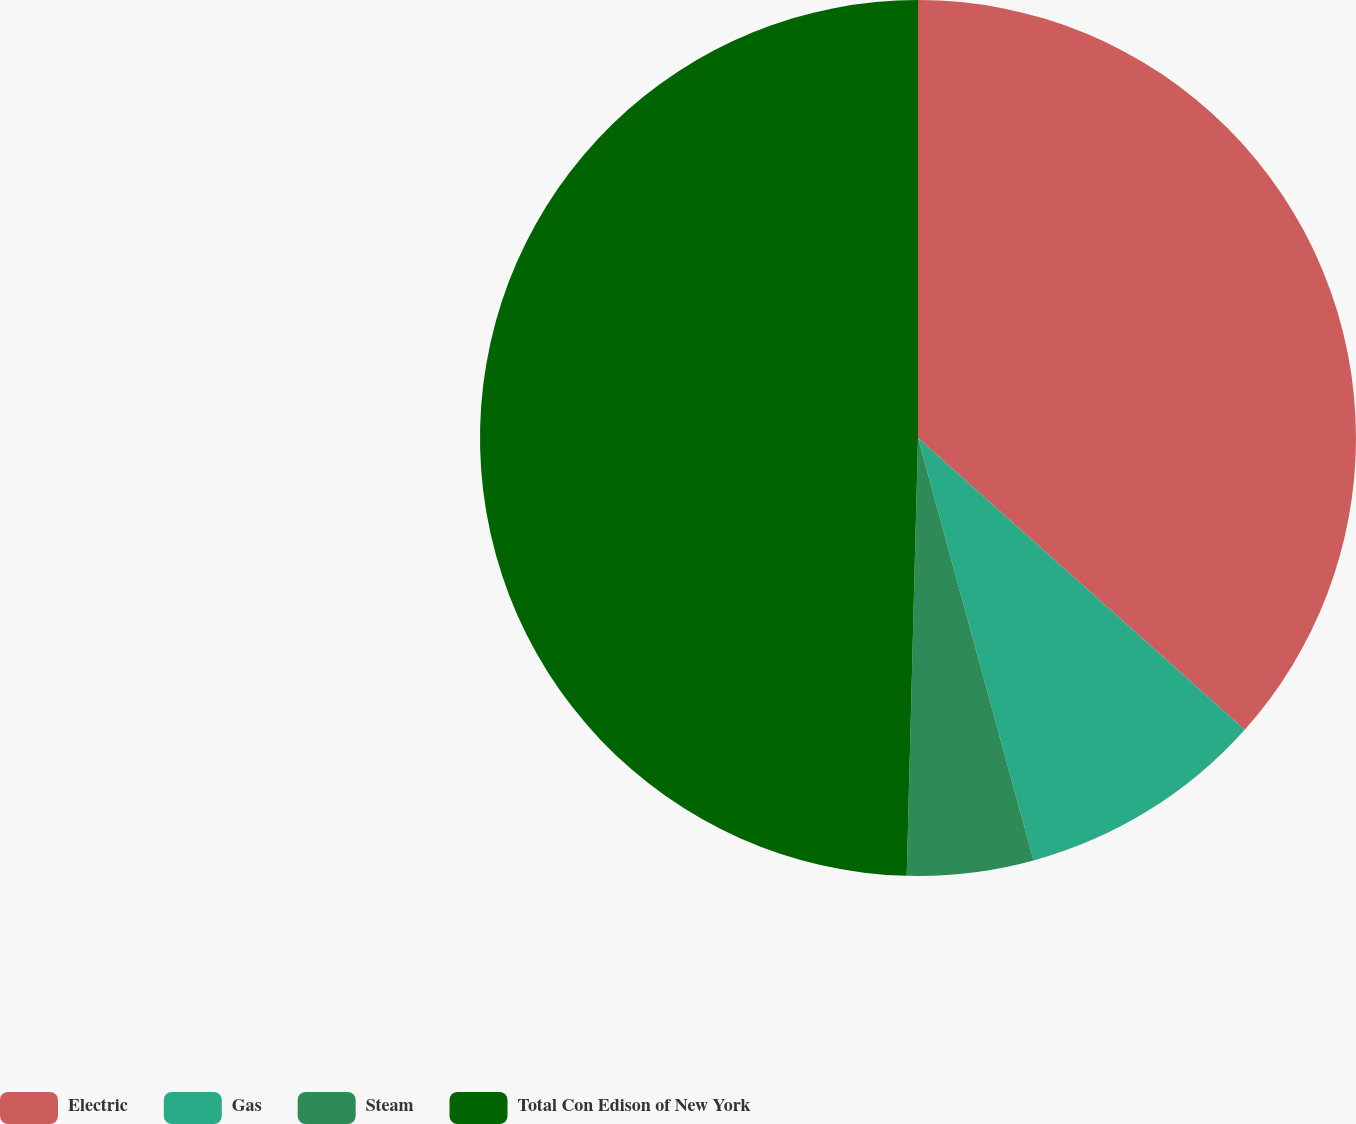Convert chart. <chart><loc_0><loc_0><loc_500><loc_500><pie_chart><fcel>Electric<fcel>Gas<fcel>Steam<fcel>Total Con Edison of New York<nl><fcel>36.6%<fcel>9.15%<fcel>4.66%<fcel>49.59%<nl></chart> 